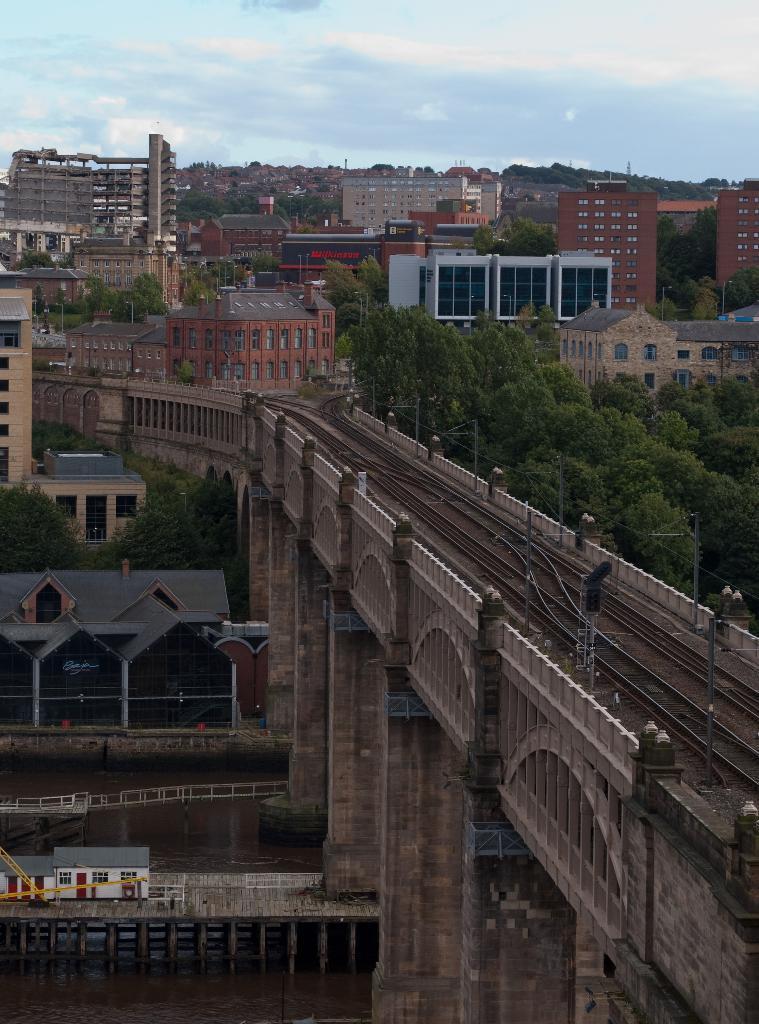In one or two sentences, can you explain what this image depicts? In this picture we can observe a railway bridge. There are some trees and buildings. In the background there is a sky with some clouds. 